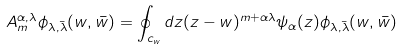Convert formula to latex. <formula><loc_0><loc_0><loc_500><loc_500>A _ { m } ^ { \alpha , \lambda } \phi _ { \lambda , \bar { \lambda } } ( w , \bar { w } ) = \oint _ { c _ { w } } d z ( z - w ) ^ { m + \alpha \lambda } \psi _ { \alpha } ( z ) \phi _ { \lambda , \bar { \lambda } } ( w , \bar { w } )</formula> 